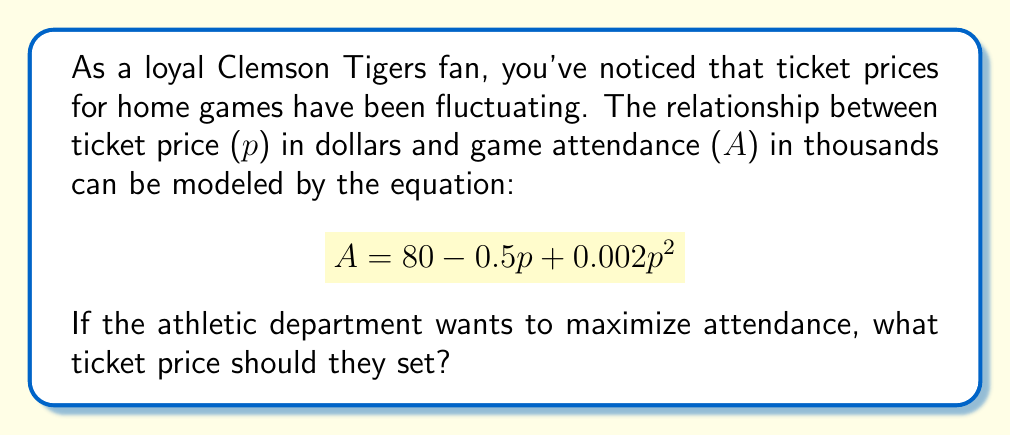Could you help me with this problem? To find the ticket price that maximizes attendance, we need to follow these steps:

1) First, we need to find the derivative of the attendance function with respect to price:

   $$ \frac{dA}{dp} = -0.5 + 0.004p $$

2) To find the maximum, we set this derivative equal to zero and solve for p:

   $$ -0.5 + 0.004p = 0 $$
   $$ 0.004p = 0.5 $$
   $$ p = \frac{0.5}{0.004} = 125 $$

3) To confirm this is a maximum (not a minimum), we can check the second derivative:

   $$ \frac{d^2A}{dp^2} = 0.004 $$

   Since this is positive, we confirm that p = 125 gives a maximum.

4) Therefore, to maximize attendance, the ticket price should be set to $125.

5) We can calculate the maximum attendance by plugging this price back into our original equation:

   $$ A = 80 - 0.5(125) + 0.002(125)^2 $$
   $$ = 80 - 62.5 + 31.25 $$
   $$ = 48.75 $$

   So the maximum attendance would be 48,750 fans.
Answer: $125 